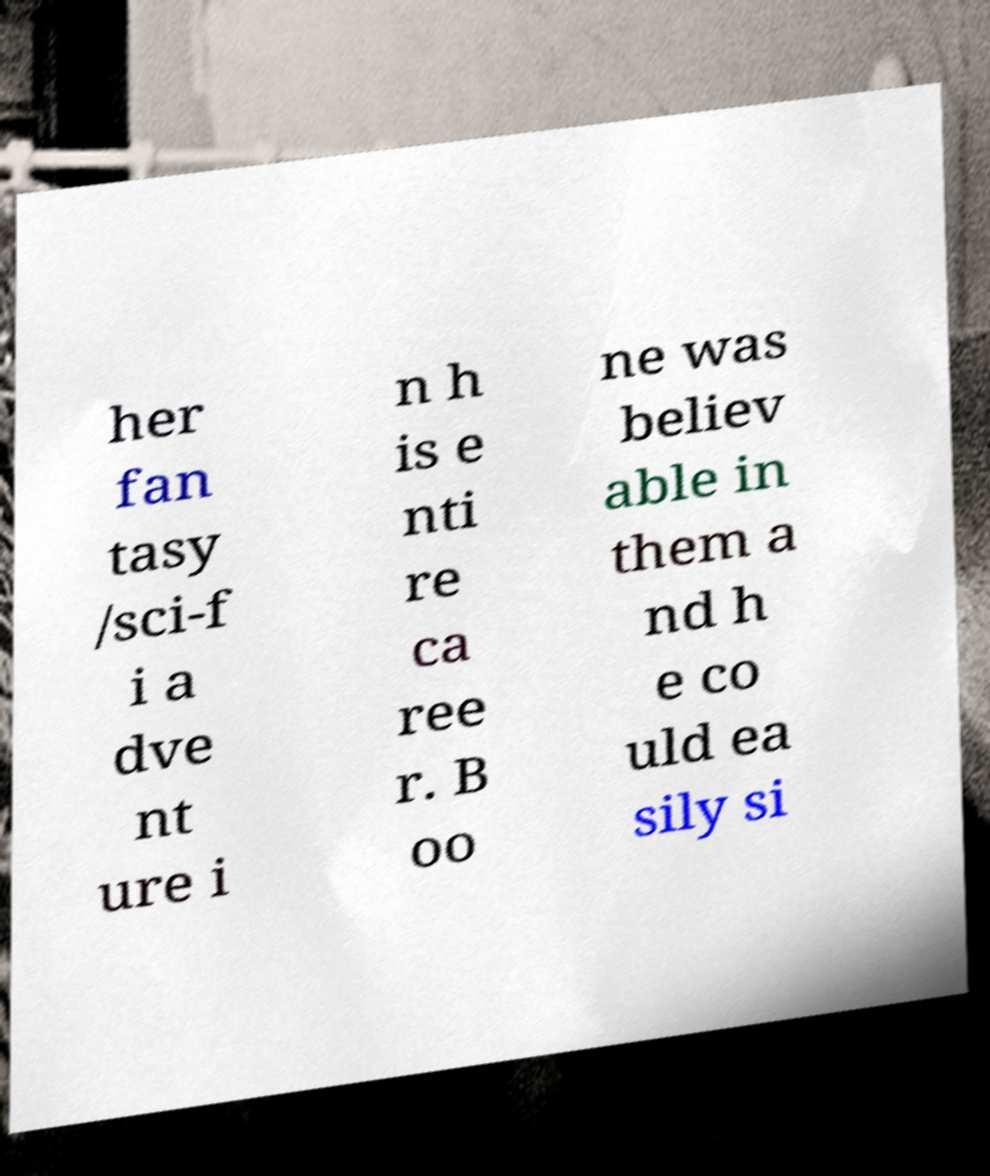For documentation purposes, I need the text within this image transcribed. Could you provide that? her fan tasy /sci-f i a dve nt ure i n h is e nti re ca ree r. B oo ne was believ able in them a nd h e co uld ea sily si 